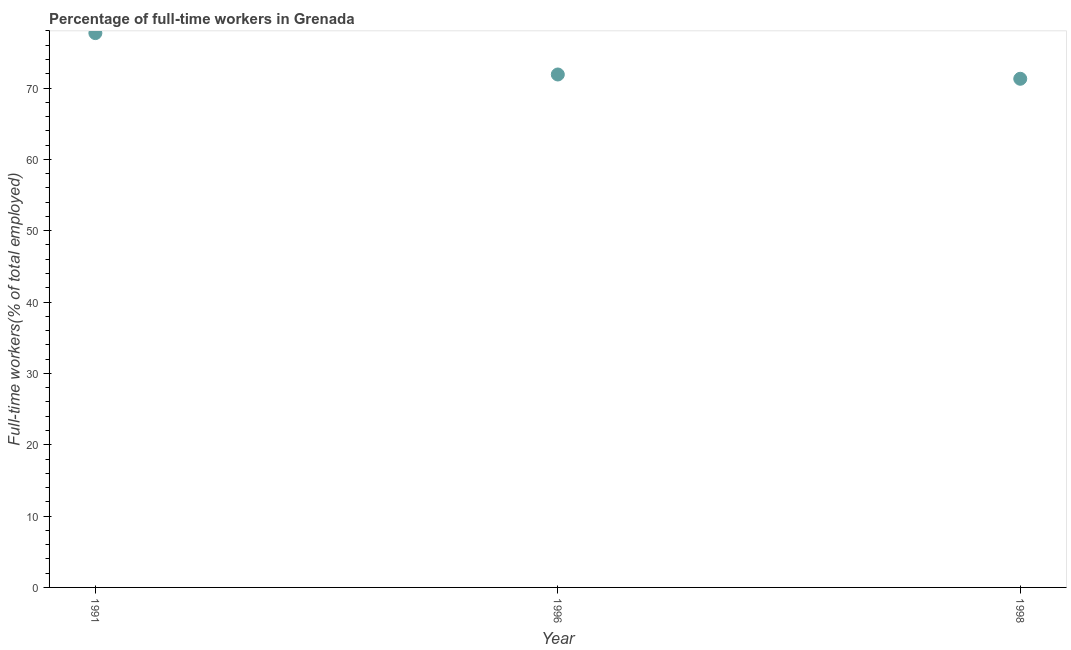What is the percentage of full-time workers in 1998?
Provide a succinct answer. 71.3. Across all years, what is the maximum percentage of full-time workers?
Ensure brevity in your answer.  77.7. Across all years, what is the minimum percentage of full-time workers?
Give a very brief answer. 71.3. In which year was the percentage of full-time workers maximum?
Your answer should be very brief. 1991. In which year was the percentage of full-time workers minimum?
Give a very brief answer. 1998. What is the sum of the percentage of full-time workers?
Your answer should be very brief. 220.9. What is the difference between the percentage of full-time workers in 1996 and 1998?
Provide a succinct answer. 0.6. What is the average percentage of full-time workers per year?
Make the answer very short. 73.63. What is the median percentage of full-time workers?
Give a very brief answer. 71.9. Do a majority of the years between 1996 and 1998 (inclusive) have percentage of full-time workers greater than 10 %?
Keep it short and to the point. Yes. What is the ratio of the percentage of full-time workers in 1996 to that in 1998?
Provide a succinct answer. 1.01. Is the percentage of full-time workers in 1996 less than that in 1998?
Your answer should be compact. No. Is the difference between the percentage of full-time workers in 1991 and 1998 greater than the difference between any two years?
Make the answer very short. Yes. What is the difference between the highest and the second highest percentage of full-time workers?
Keep it short and to the point. 5.8. What is the difference between the highest and the lowest percentage of full-time workers?
Your response must be concise. 6.4. How many dotlines are there?
Keep it short and to the point. 1. Are the values on the major ticks of Y-axis written in scientific E-notation?
Offer a terse response. No. Does the graph contain any zero values?
Your answer should be very brief. No. What is the title of the graph?
Offer a terse response. Percentage of full-time workers in Grenada. What is the label or title of the X-axis?
Provide a short and direct response. Year. What is the label or title of the Y-axis?
Offer a terse response. Full-time workers(% of total employed). What is the Full-time workers(% of total employed) in 1991?
Your answer should be very brief. 77.7. What is the Full-time workers(% of total employed) in 1996?
Offer a very short reply. 71.9. What is the Full-time workers(% of total employed) in 1998?
Provide a succinct answer. 71.3. What is the difference between the Full-time workers(% of total employed) in 1991 and 1998?
Keep it short and to the point. 6.4. What is the ratio of the Full-time workers(% of total employed) in 1991 to that in 1996?
Your answer should be very brief. 1.08. What is the ratio of the Full-time workers(% of total employed) in 1991 to that in 1998?
Provide a succinct answer. 1.09. What is the ratio of the Full-time workers(% of total employed) in 1996 to that in 1998?
Provide a succinct answer. 1.01. 